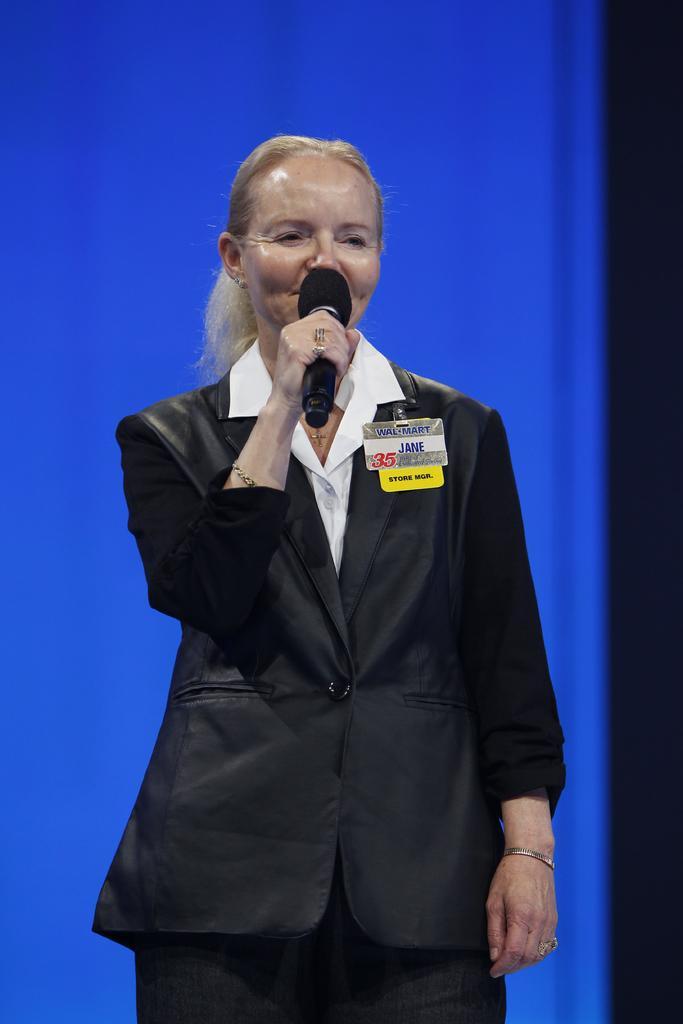Please provide a concise description of this image. In this image we can see a woman standing and holding a mic and it looks like she is talking. The background is blue in color. 